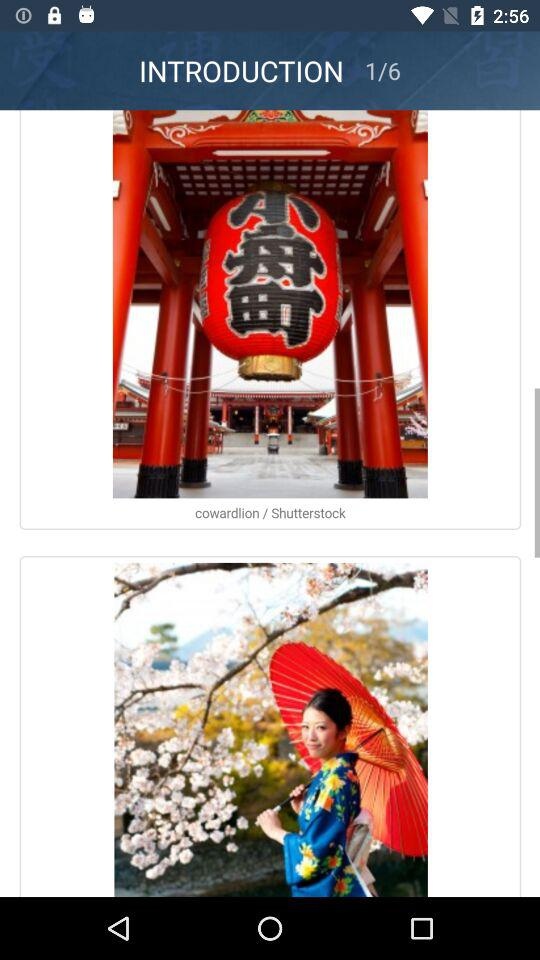Which is the current image number? The current image number is 1. 